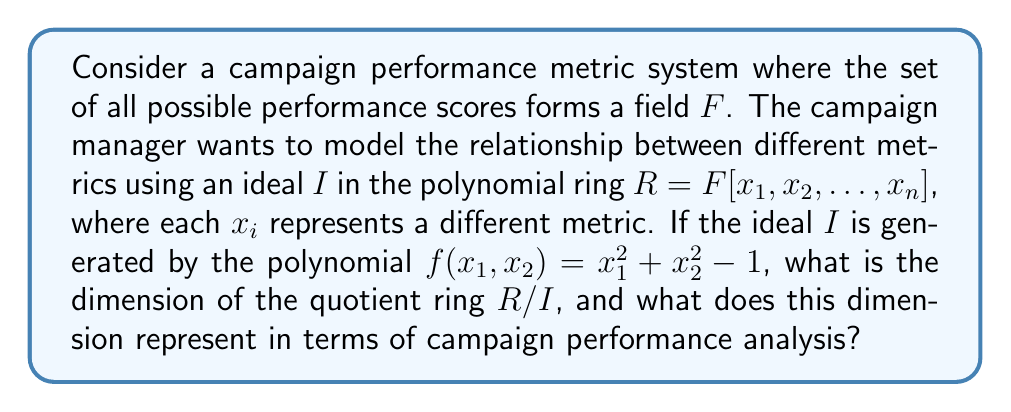Show me your answer to this math problem. To solve this problem, we need to follow these steps:

1) First, we need to understand what the polynomial $f(x_1, x_2) = x_1^2 + x_2^2 - 1$ represents. This is the equation of a unit circle in the $x_1x_2$-plane.

2) The ideal $I = \langle f(x_1, x_2) \rangle$ in $R = F[x_1, x_2, \ldots, x_n]$ represents all polynomials that are multiples of $f(x_1, x_2)$.

3) The quotient ring $R/I$ consists of all equivalence classes of polynomials modulo $I$. In other words, two polynomials are equivalent if their difference is in $I$.

4) The dimension of $R/I$ is equal to the dimension of the variety $V(I)$, which is the set of all points in $F^n$ that satisfy the equation $f(x_1, x_2) = 0$.

5) The variety $V(I)$ is a circle in the $x_1x_2$-plane, which is a 1-dimensional object. The other $n-2$ variables are free.

6) Therefore, the dimension of $R/I$ is $n-1$.

In terms of campaign performance analysis, this dimension represents the degrees of freedom in the metric space after imposing the constraint $f(x_1, x_2) = 0$. It means that out of $n$ metrics, we can freely choose values for $n-1$ of them, and the last one will be determined by the constraint.
Answer: The dimension of the quotient ring $R/I$ is $n-1$, where $n$ is the total number of metrics. This represents the number of independently variable metrics in the constrained performance model. 